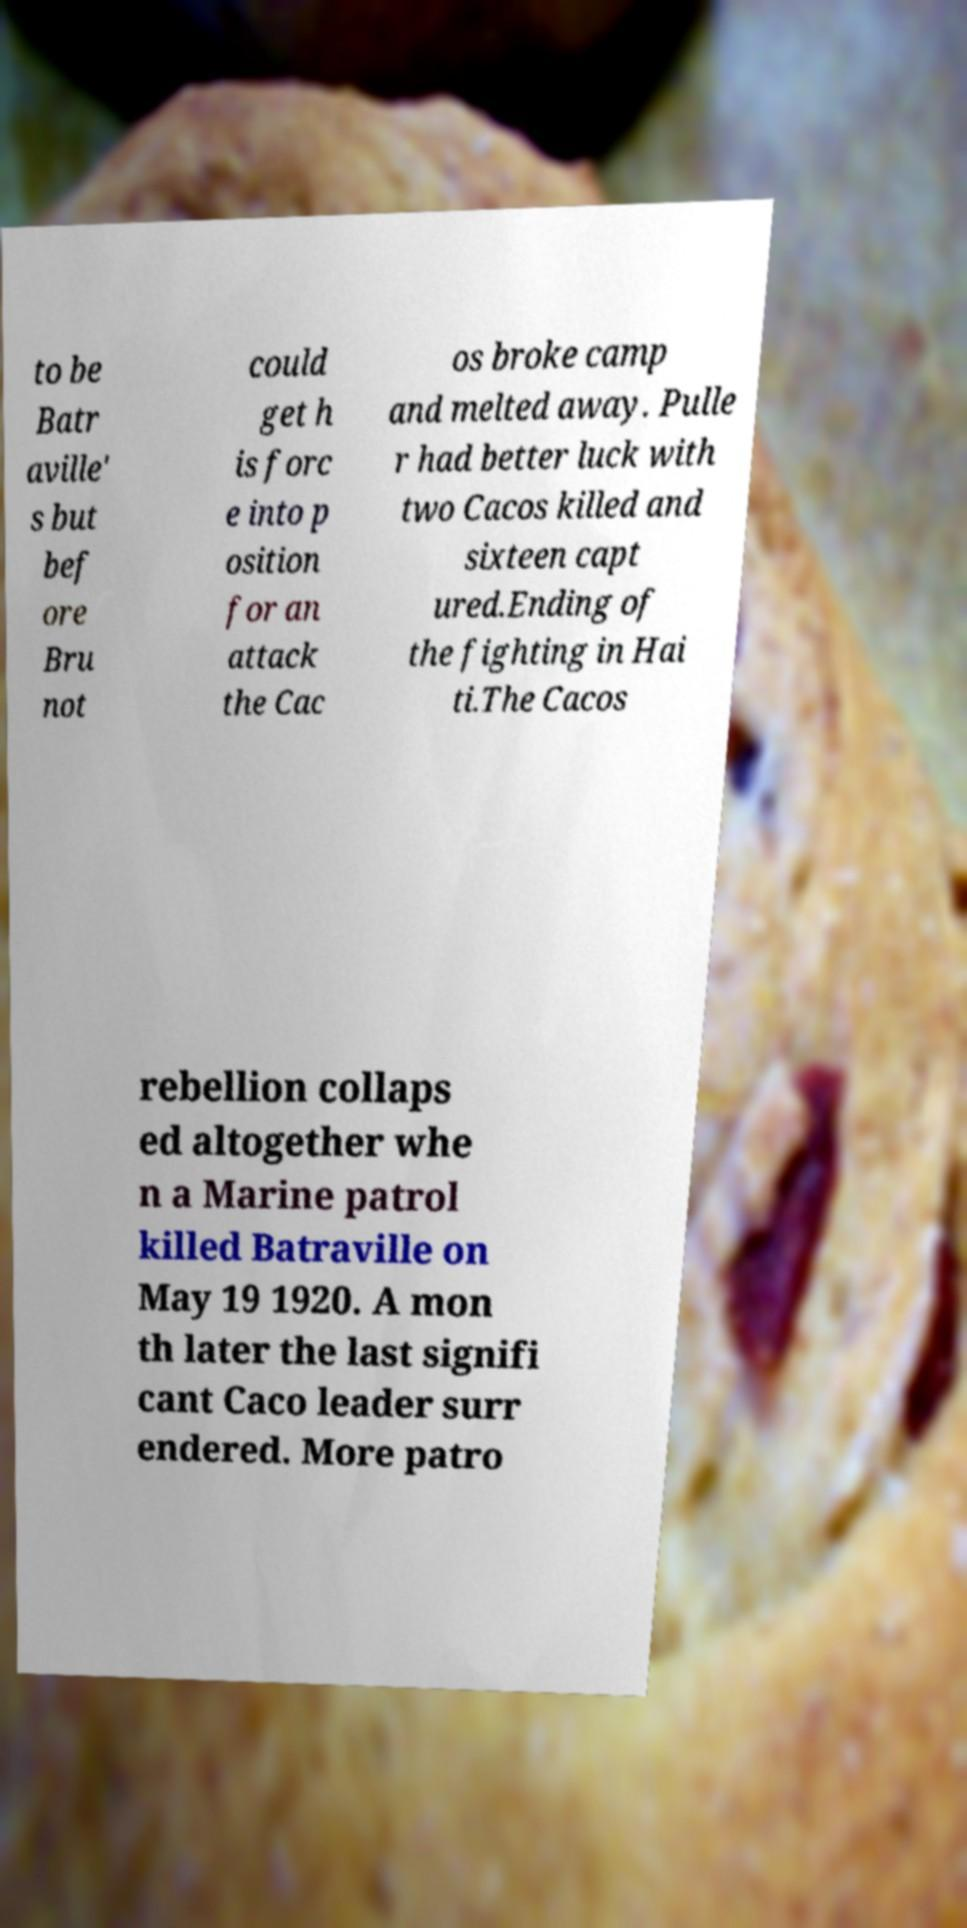Could you extract and type out the text from this image? to be Batr aville' s but bef ore Bru not could get h is forc e into p osition for an attack the Cac os broke camp and melted away. Pulle r had better luck with two Cacos killed and sixteen capt ured.Ending of the fighting in Hai ti.The Cacos rebellion collaps ed altogether whe n a Marine patrol killed Batraville on May 19 1920. A mon th later the last signifi cant Caco leader surr endered. More patro 